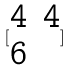<formula> <loc_0><loc_0><loc_500><loc_500>[ \begin{matrix} 4 & 4 \\ 6 \end{matrix} ]</formula> 